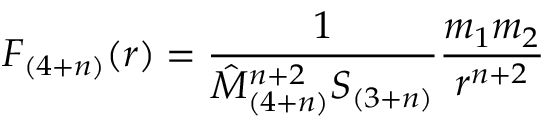<formula> <loc_0><loc_0><loc_500><loc_500>F _ { ( 4 + n ) } ( r ) = \frac { 1 } { \hat { M } _ { ( 4 + n ) } ^ { n + 2 } S _ { ( 3 + n ) } } \frac { m _ { 1 } m _ { 2 } } { r ^ { n + 2 } }</formula> 